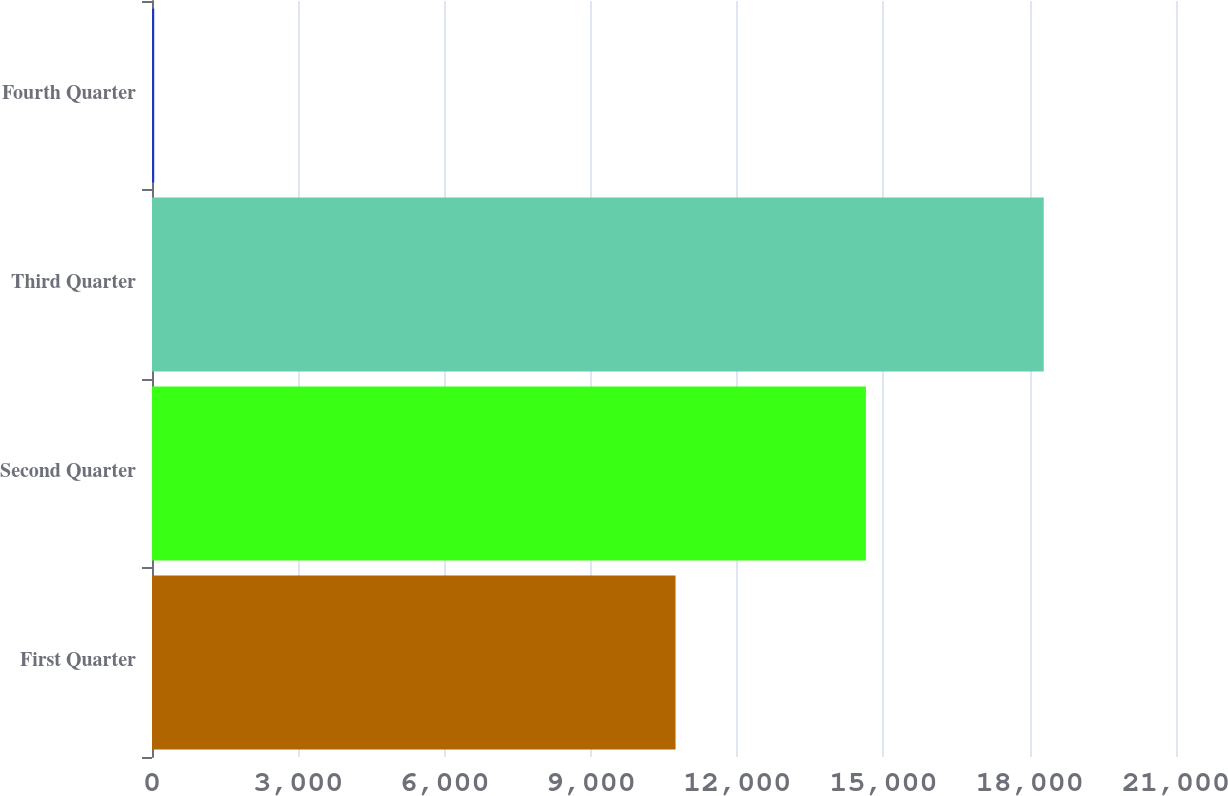<chart> <loc_0><loc_0><loc_500><loc_500><bar_chart><fcel>First Quarter<fcel>Second Quarter<fcel>Third Quarter<fcel>Fourth Quarter<nl><fcel>10737<fcel>14641<fcel>18288<fcel>46<nl></chart> 